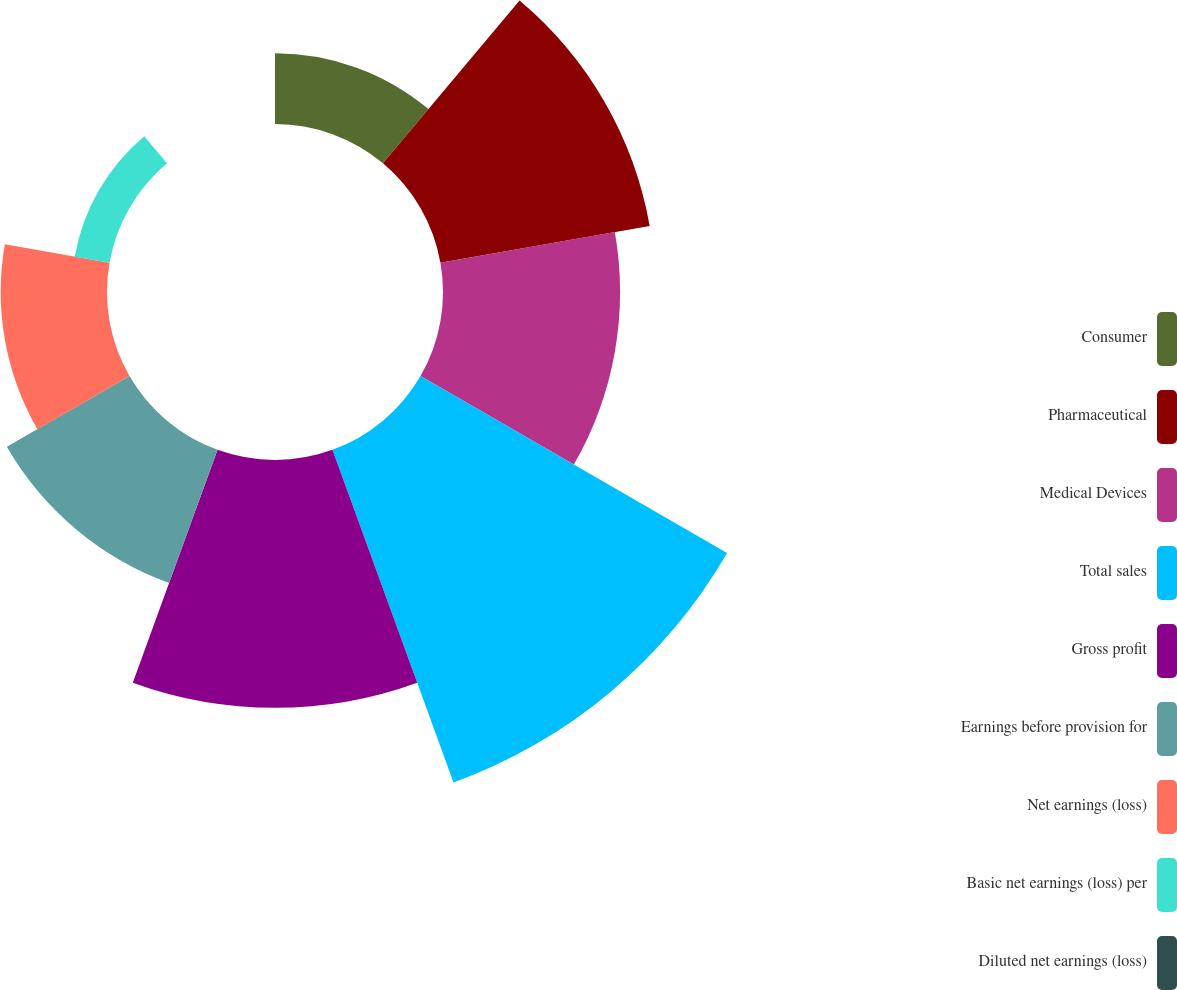<chart> <loc_0><loc_0><loc_500><loc_500><pie_chart><fcel>Consumer<fcel>Pharmaceutical<fcel>Medical Devices<fcel>Total sales<fcel>Gross profit<fcel>Earnings before provision for<fcel>Net earnings (loss)<fcel>Basic net earnings (loss) per<fcel>Diluted net earnings (loss)<nl><fcel>5.26%<fcel>15.79%<fcel>13.16%<fcel>26.31%<fcel>18.42%<fcel>10.53%<fcel>7.9%<fcel>2.63%<fcel>0.0%<nl></chart> 